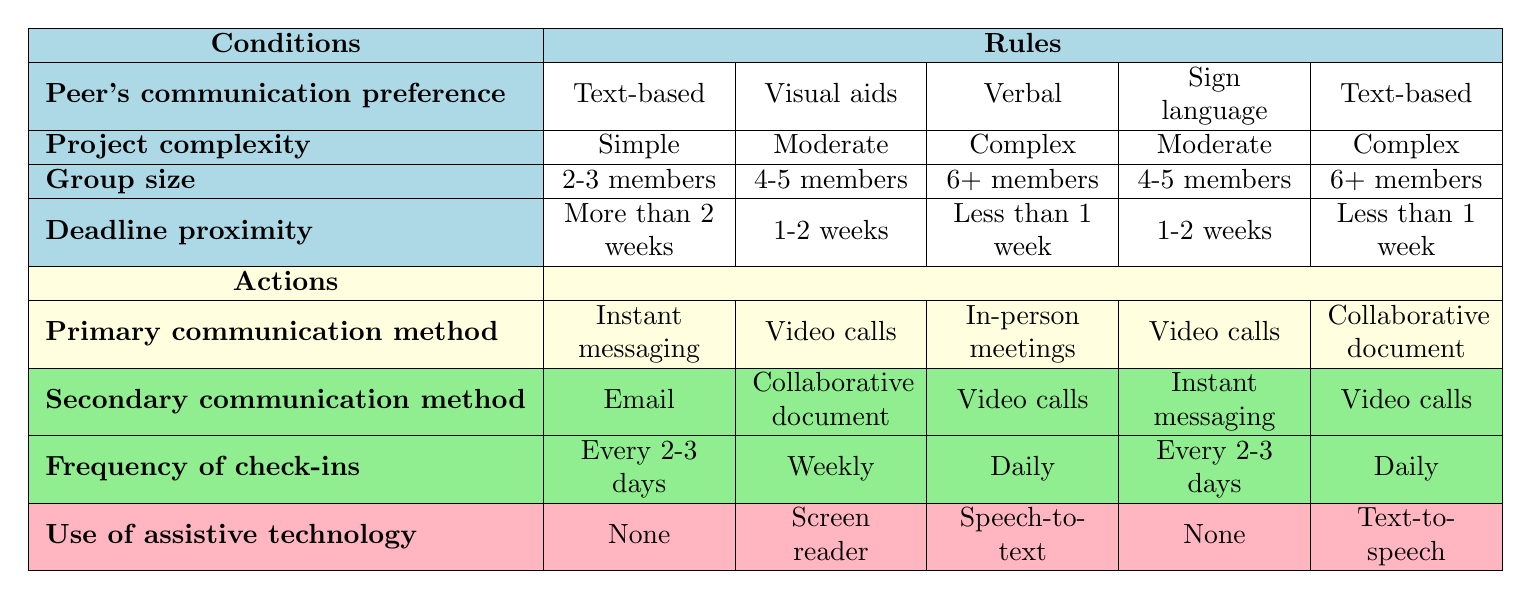What is the primary communication method for a project with simple complexity and 2-3 members? According to the table, for a project that has a simple complexity and involves 2-3 members, the primary communication method is listed as "Instant messaging".
Answer: Instant messaging For a project that is complex and has 6 or more members, what is the secondary communication method? In the table, under the conditions of a complex project with a group size of 6 or more members, the secondary communication method is "Video calls".
Answer: Video calls Is "Screen reader" used as assistive technology when the project complexity is moderate and the group size is 4-5 members? The table indicates that when the project complexity is moderate and the group size is 4-5 members (regardless of the communication preference), the assistive technology used is "Screen reader". Therefore, the statement is true.
Answer: Yes What is the frequency of check-ins for a project that has a verbal communication preference and a deadline of less than 1 week? For a project with a verbal communication preference and a deadline proximity of less than 1 week (with 6 or more members), the frequency of check-ins is "Daily".
Answer: Daily How many different primary communication methods could be used if the peer's communication preference is "Sign language"? The table lists two different primary communication methods for projects where the peer's communication preference is "Sign language": "Video calls" and "In-person meetings".
Answer: 2 If we combine the primary communication methods for "Text-based" and "Verbal", what are the unique methods mentioned in the rules? For the "Text-based" preference, the primary method is "Instant messaging" and for the "Verbal" preference, it is "In-person meetings". The unique methods are "Instant messaging" and "In-person meetings", totaling to 2 unique methods.
Answer: 2 What is the primary communication method for a moderate complexity project with visual aids and a deadline of 1-2 weeks? By checking the conditions for a project with a "Visual aids" preference, "Moderate" complexity, and a "1-2 weeks" deadline, the table specifies the primary communication method is "Video calls".
Answer: Video calls Are collaborative documents used in projects with less than a week deadline for complex projects? The table specifies for complex projects with less than a week deadline (and peer's preference being text-based) that the primary communication method is "Collaborative document". Thus, "Yes", collaborative documents are used.
Answer: Yes 